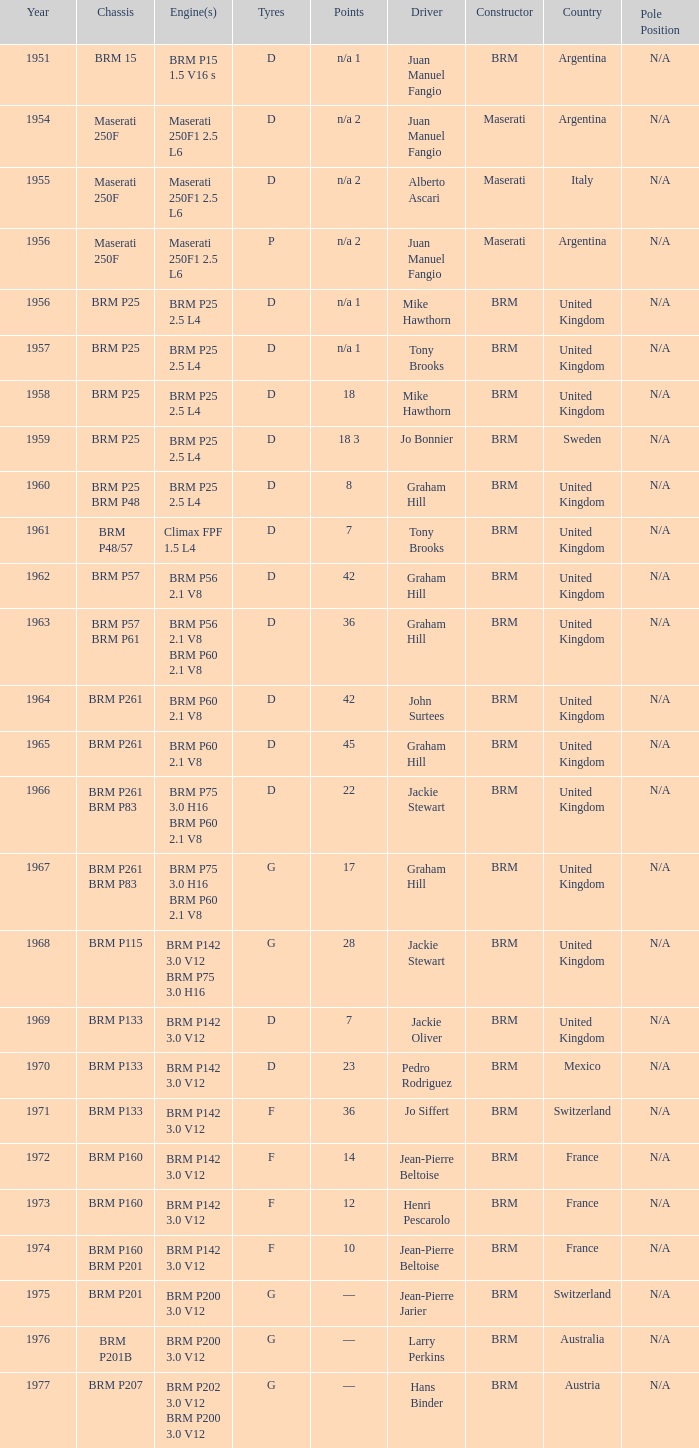Name the sum of year for engine of brm p202 3.0 v12 brm p200 3.0 v12 1977.0. 